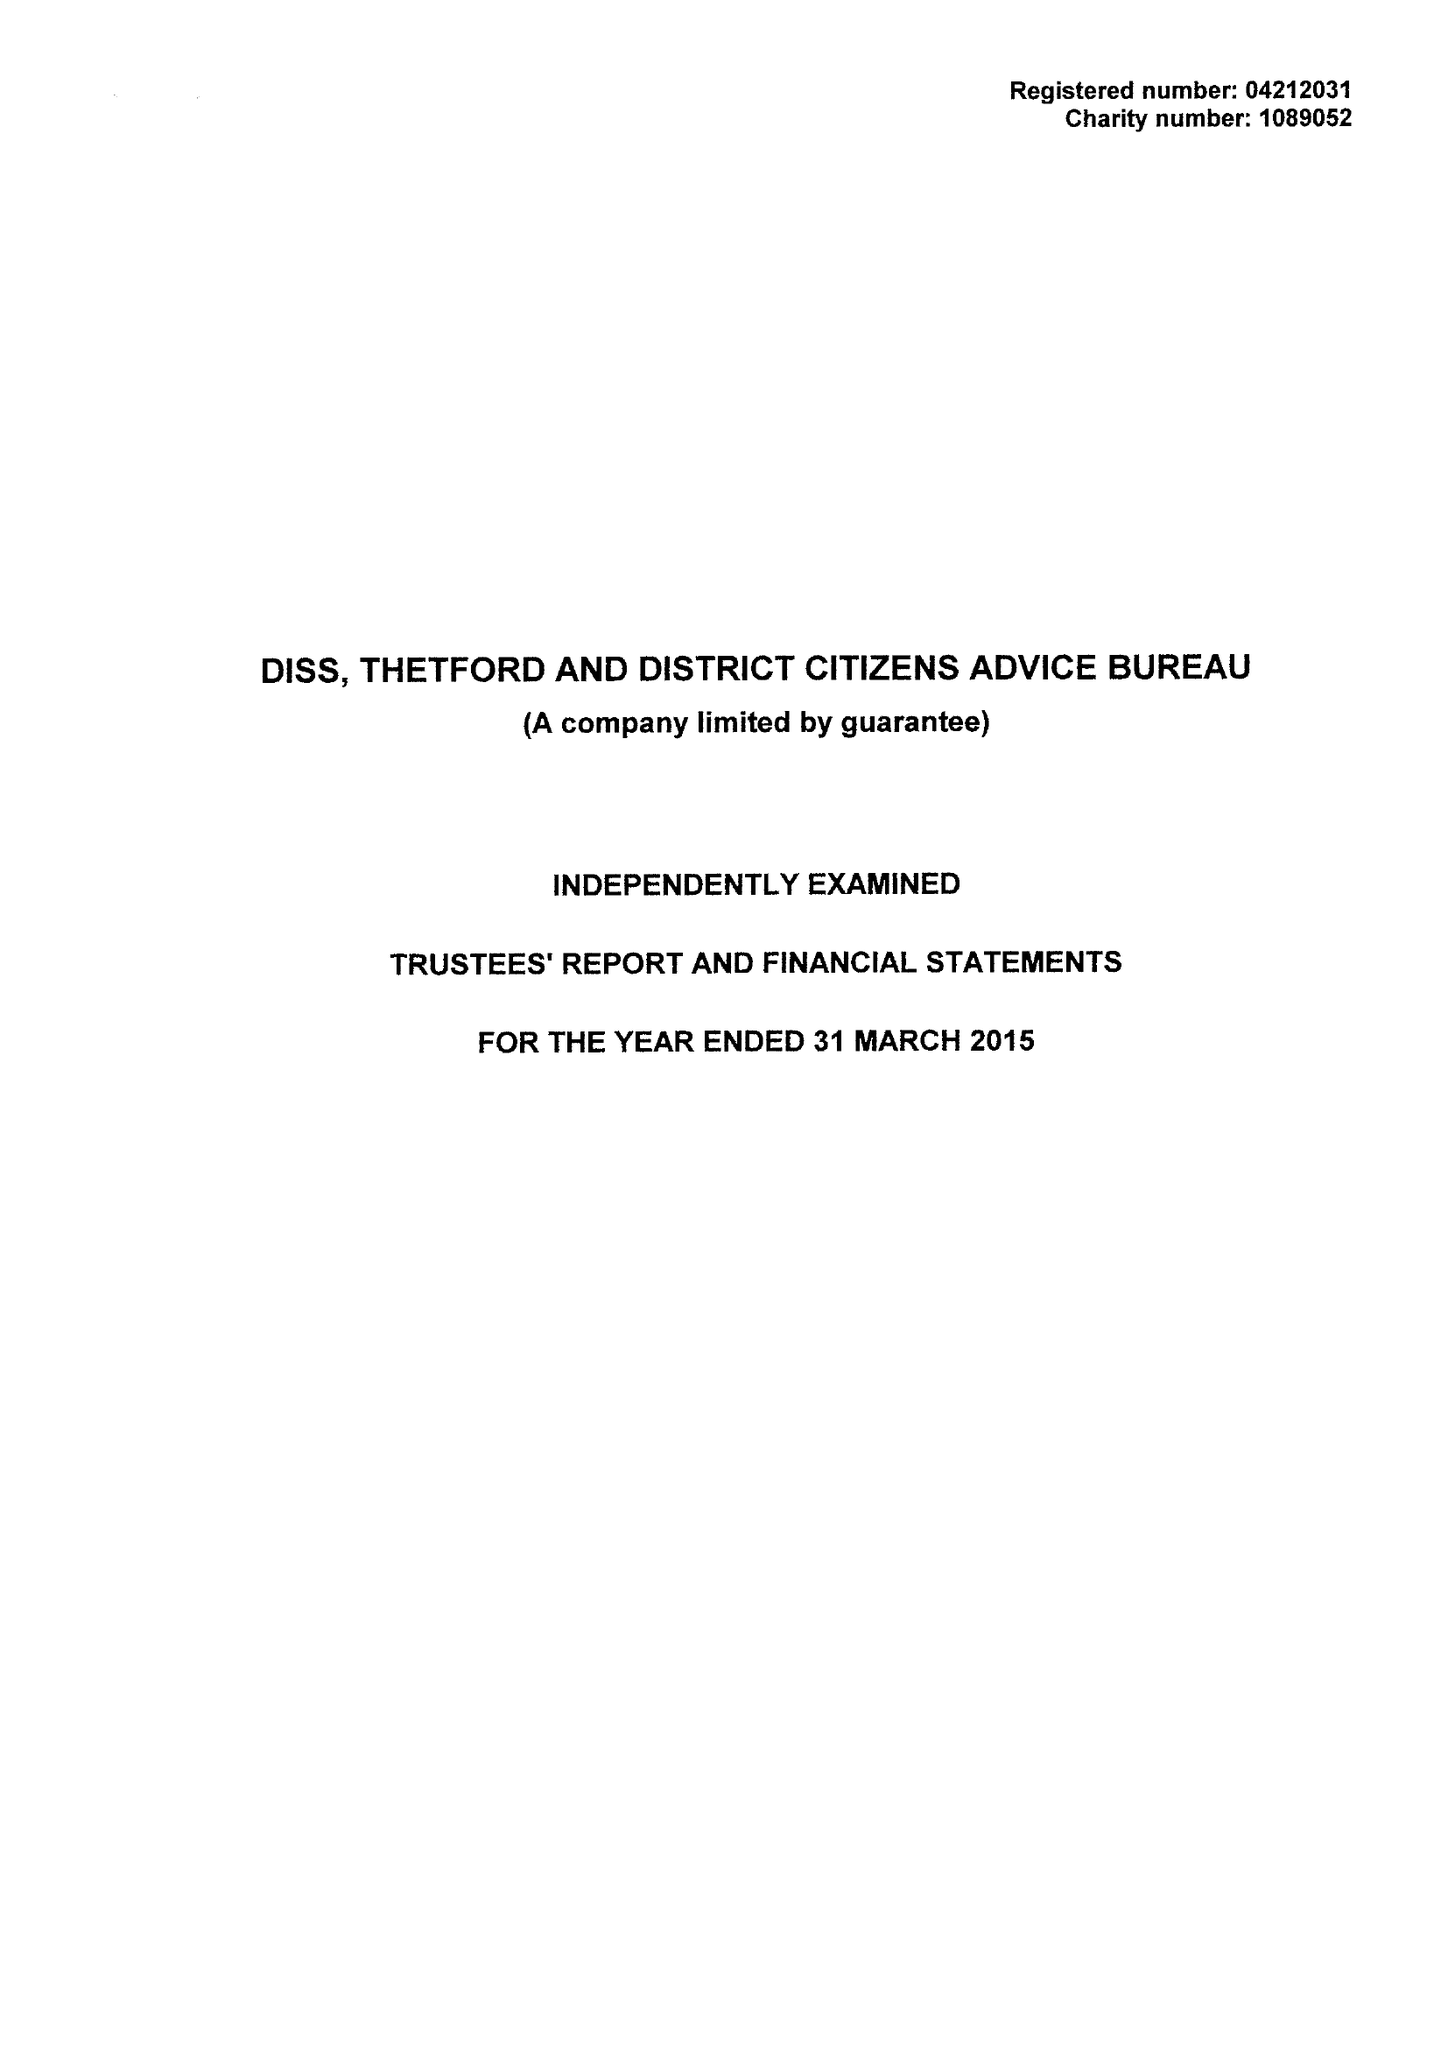What is the value for the income_annually_in_british_pounds?
Answer the question using a single word or phrase. 453550.00 